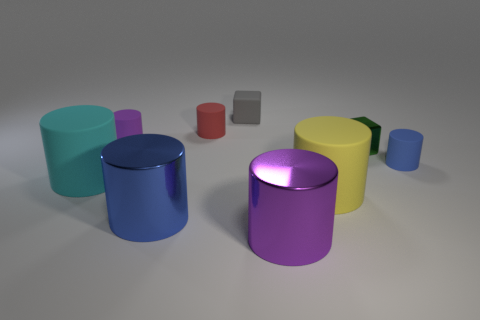There is a matte thing that is to the right of the cyan object and in front of the small blue cylinder; what is its shape?
Your answer should be compact. Cylinder. There is a shiny thing behind the blue rubber object; what is its size?
Your answer should be very brief. Small. What number of tiny red objects are the same shape as the big yellow thing?
Your response must be concise. 1. How many objects are rubber cylinders that are in front of the blue matte thing or shiny objects in front of the tiny metal block?
Make the answer very short. 4. How many yellow things are rubber balls or small cylinders?
Make the answer very short. 0. What is the large cylinder that is right of the gray cube and behind the purple metallic cylinder made of?
Your answer should be very brief. Rubber. Is the red cylinder made of the same material as the big yellow thing?
Offer a terse response. Yes. How many green things are the same size as the gray block?
Make the answer very short. 1. Are there an equal number of cyan things to the left of the tiny green metal object and small red cylinders?
Ensure brevity in your answer.  Yes. How many matte objects are in front of the small blue object and on the left side of the purple shiny thing?
Offer a terse response. 1. 